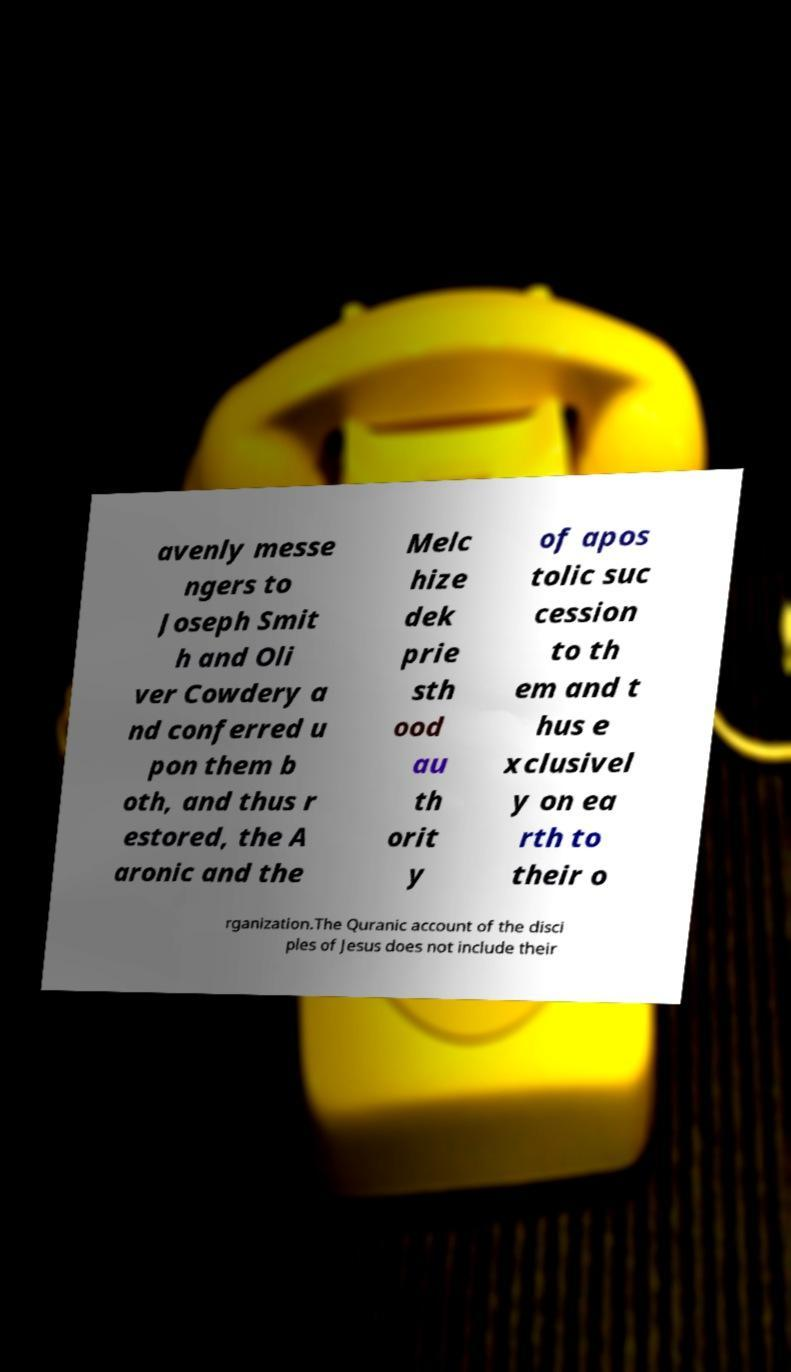Can you accurately transcribe the text from the provided image for me? avenly messe ngers to Joseph Smit h and Oli ver Cowdery a nd conferred u pon them b oth, and thus r estored, the A aronic and the Melc hize dek prie sth ood au th orit y of apos tolic suc cession to th em and t hus e xclusivel y on ea rth to their o rganization.The Quranic account of the disci ples of Jesus does not include their 